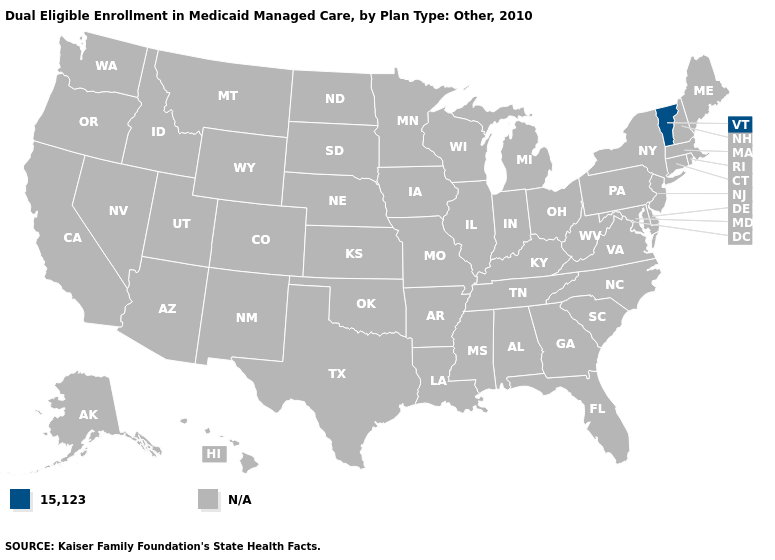Name the states that have a value in the range N/A?
Concise answer only. Alabama, Alaska, Arizona, Arkansas, California, Colorado, Connecticut, Delaware, Florida, Georgia, Hawaii, Idaho, Illinois, Indiana, Iowa, Kansas, Kentucky, Louisiana, Maine, Maryland, Massachusetts, Michigan, Minnesota, Mississippi, Missouri, Montana, Nebraska, Nevada, New Hampshire, New Jersey, New Mexico, New York, North Carolina, North Dakota, Ohio, Oklahoma, Oregon, Pennsylvania, Rhode Island, South Carolina, South Dakota, Tennessee, Texas, Utah, Virginia, Washington, West Virginia, Wisconsin, Wyoming. What is the value of North Carolina?
Keep it brief. N/A. Name the states that have a value in the range 15,123?
Be succinct. Vermont. Name the states that have a value in the range N/A?
Be succinct. Alabama, Alaska, Arizona, Arkansas, California, Colorado, Connecticut, Delaware, Florida, Georgia, Hawaii, Idaho, Illinois, Indiana, Iowa, Kansas, Kentucky, Louisiana, Maine, Maryland, Massachusetts, Michigan, Minnesota, Mississippi, Missouri, Montana, Nebraska, Nevada, New Hampshire, New Jersey, New Mexico, New York, North Carolina, North Dakota, Ohio, Oklahoma, Oregon, Pennsylvania, Rhode Island, South Carolina, South Dakota, Tennessee, Texas, Utah, Virginia, Washington, West Virginia, Wisconsin, Wyoming. What is the value of Texas?
Write a very short answer. N/A. Name the states that have a value in the range N/A?
Keep it brief. Alabama, Alaska, Arizona, Arkansas, California, Colorado, Connecticut, Delaware, Florida, Georgia, Hawaii, Idaho, Illinois, Indiana, Iowa, Kansas, Kentucky, Louisiana, Maine, Maryland, Massachusetts, Michigan, Minnesota, Mississippi, Missouri, Montana, Nebraska, Nevada, New Hampshire, New Jersey, New Mexico, New York, North Carolina, North Dakota, Ohio, Oklahoma, Oregon, Pennsylvania, Rhode Island, South Carolina, South Dakota, Tennessee, Texas, Utah, Virginia, Washington, West Virginia, Wisconsin, Wyoming. How many symbols are there in the legend?
Be succinct. 2. 